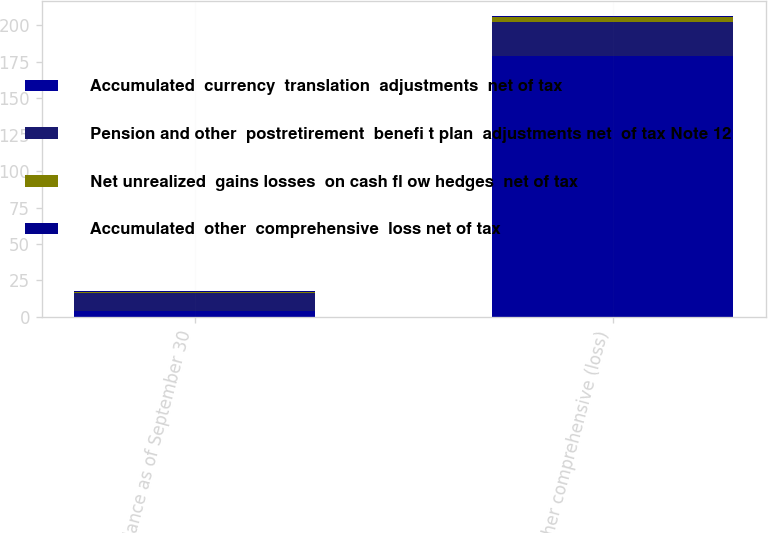Convert chart to OTSL. <chart><loc_0><loc_0><loc_500><loc_500><stacked_bar_chart><ecel><fcel>Balance as of September 30<fcel>Other comprehensive (loss)<nl><fcel>Accumulated  currency  translation  adjustments  net of tax<fcel>3.9<fcel>178.7<nl><fcel>Pension and other  postretirement  benefi t plan  adjustments net  of tax Note 12<fcel>12.1<fcel>23.4<nl><fcel>Net unrealized  gains losses  on cash fl ow hedges  net of tax<fcel>1.3<fcel>3.9<nl><fcel>Accumulated  other  comprehensive  loss net of tax<fcel>0.3<fcel>0.3<nl></chart> 